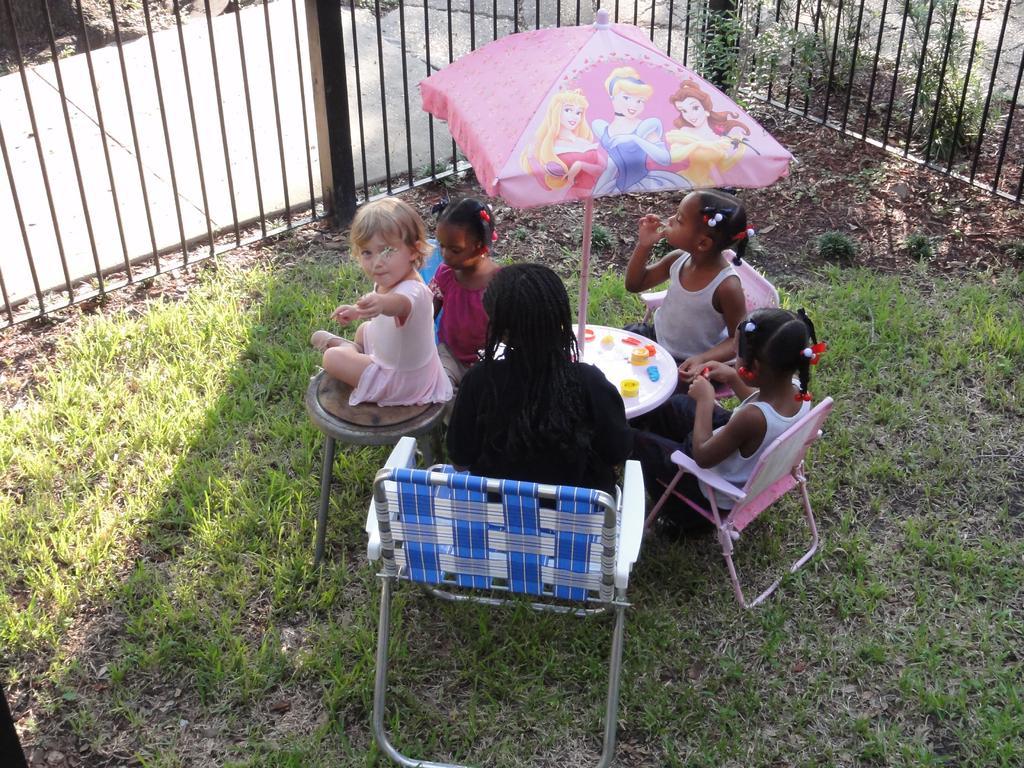Could you give a brief overview of what you see in this image? Here we can see a group of children sitting on chairs with table in front of them and there is a umbrella placed on the table and in front of them we can see a railing 